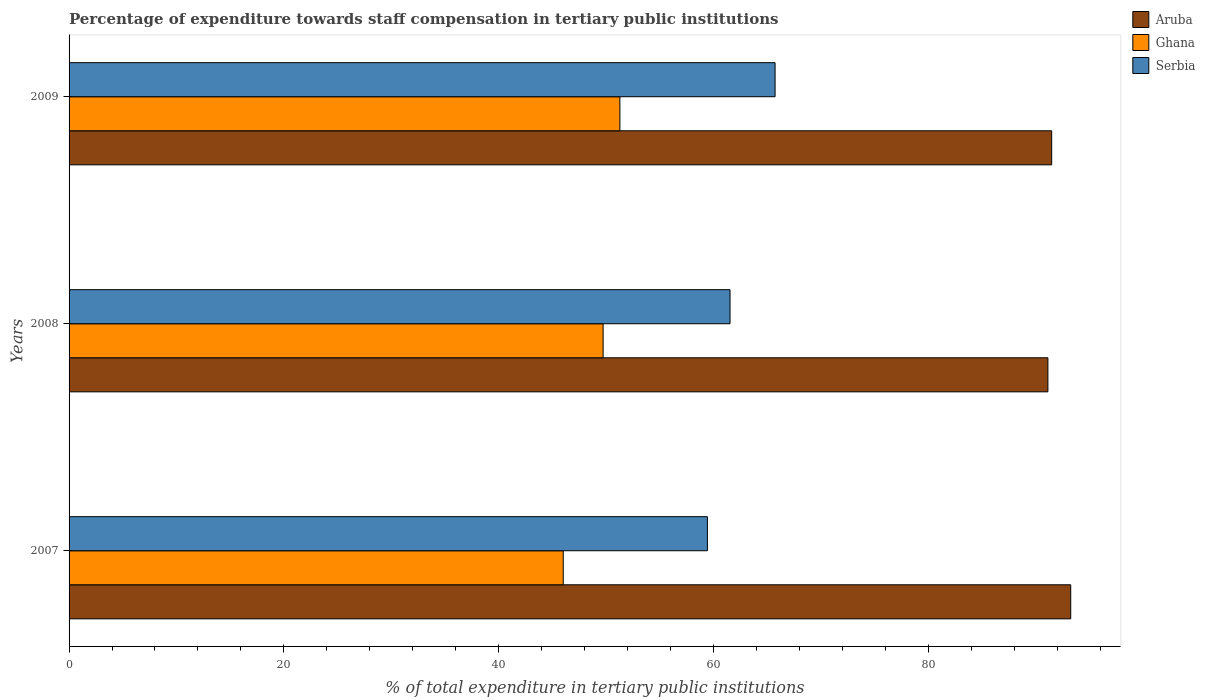How many groups of bars are there?
Keep it short and to the point. 3. Are the number of bars per tick equal to the number of legend labels?
Your answer should be compact. Yes. Are the number of bars on each tick of the Y-axis equal?
Provide a succinct answer. Yes. How many bars are there on the 1st tick from the bottom?
Provide a short and direct response. 3. What is the label of the 3rd group of bars from the top?
Make the answer very short. 2007. What is the percentage of expenditure towards staff compensation in Ghana in 2007?
Provide a short and direct response. 46.02. Across all years, what is the maximum percentage of expenditure towards staff compensation in Serbia?
Offer a terse response. 65.74. Across all years, what is the minimum percentage of expenditure towards staff compensation in Aruba?
Provide a succinct answer. 91.15. In which year was the percentage of expenditure towards staff compensation in Serbia maximum?
Provide a succinct answer. 2009. In which year was the percentage of expenditure towards staff compensation in Serbia minimum?
Give a very brief answer. 2007. What is the total percentage of expenditure towards staff compensation in Ghana in the graph?
Keep it short and to the point. 147.04. What is the difference between the percentage of expenditure towards staff compensation in Aruba in 2008 and that in 2009?
Provide a succinct answer. -0.35. What is the difference between the percentage of expenditure towards staff compensation in Serbia in 2009 and the percentage of expenditure towards staff compensation in Aruba in 2007?
Ensure brevity in your answer.  -27.53. What is the average percentage of expenditure towards staff compensation in Aruba per year?
Provide a short and direct response. 91.97. In the year 2007, what is the difference between the percentage of expenditure towards staff compensation in Serbia and percentage of expenditure towards staff compensation in Aruba?
Offer a terse response. -33.83. In how many years, is the percentage of expenditure towards staff compensation in Aruba greater than 24 %?
Keep it short and to the point. 3. What is the ratio of the percentage of expenditure towards staff compensation in Aruba in 2008 to that in 2009?
Provide a short and direct response. 1. Is the difference between the percentage of expenditure towards staff compensation in Serbia in 2007 and 2009 greater than the difference between the percentage of expenditure towards staff compensation in Aruba in 2007 and 2009?
Your answer should be compact. No. What is the difference between the highest and the second highest percentage of expenditure towards staff compensation in Aruba?
Your response must be concise. 1.77. What is the difference between the highest and the lowest percentage of expenditure towards staff compensation in Ghana?
Offer a very short reply. 5.27. Is the sum of the percentage of expenditure towards staff compensation in Aruba in 2008 and 2009 greater than the maximum percentage of expenditure towards staff compensation in Serbia across all years?
Your answer should be compact. Yes. What does the 1st bar from the top in 2009 represents?
Give a very brief answer. Serbia. What does the 3rd bar from the bottom in 2008 represents?
Offer a terse response. Serbia. Is it the case that in every year, the sum of the percentage of expenditure towards staff compensation in Ghana and percentage of expenditure towards staff compensation in Serbia is greater than the percentage of expenditure towards staff compensation in Aruba?
Offer a terse response. Yes. How many bars are there?
Make the answer very short. 9. Are all the bars in the graph horizontal?
Your response must be concise. Yes. How many years are there in the graph?
Give a very brief answer. 3. Are the values on the major ticks of X-axis written in scientific E-notation?
Your response must be concise. No. Where does the legend appear in the graph?
Ensure brevity in your answer.  Top right. What is the title of the graph?
Your answer should be very brief. Percentage of expenditure towards staff compensation in tertiary public institutions. Does "Gabon" appear as one of the legend labels in the graph?
Offer a terse response. No. What is the label or title of the X-axis?
Your answer should be compact. % of total expenditure in tertiary public institutions. What is the label or title of the Y-axis?
Provide a short and direct response. Years. What is the % of total expenditure in tertiary public institutions in Aruba in 2007?
Offer a terse response. 93.27. What is the % of total expenditure in tertiary public institutions of Ghana in 2007?
Offer a very short reply. 46.02. What is the % of total expenditure in tertiary public institutions of Serbia in 2007?
Give a very brief answer. 59.44. What is the % of total expenditure in tertiary public institutions of Aruba in 2008?
Make the answer very short. 91.15. What is the % of total expenditure in tertiary public institutions in Ghana in 2008?
Keep it short and to the point. 49.73. What is the % of total expenditure in tertiary public institutions of Serbia in 2008?
Offer a terse response. 61.55. What is the % of total expenditure in tertiary public institutions of Aruba in 2009?
Give a very brief answer. 91.5. What is the % of total expenditure in tertiary public institutions in Ghana in 2009?
Your answer should be very brief. 51.29. What is the % of total expenditure in tertiary public institutions of Serbia in 2009?
Make the answer very short. 65.74. Across all years, what is the maximum % of total expenditure in tertiary public institutions of Aruba?
Offer a terse response. 93.27. Across all years, what is the maximum % of total expenditure in tertiary public institutions of Ghana?
Your response must be concise. 51.29. Across all years, what is the maximum % of total expenditure in tertiary public institutions in Serbia?
Provide a succinct answer. 65.74. Across all years, what is the minimum % of total expenditure in tertiary public institutions of Aruba?
Your answer should be compact. 91.15. Across all years, what is the minimum % of total expenditure in tertiary public institutions in Ghana?
Your answer should be very brief. 46.02. Across all years, what is the minimum % of total expenditure in tertiary public institutions of Serbia?
Your answer should be very brief. 59.44. What is the total % of total expenditure in tertiary public institutions in Aruba in the graph?
Offer a very short reply. 275.92. What is the total % of total expenditure in tertiary public institutions in Ghana in the graph?
Your answer should be compact. 147.04. What is the total % of total expenditure in tertiary public institutions in Serbia in the graph?
Provide a succinct answer. 186.73. What is the difference between the % of total expenditure in tertiary public institutions of Aruba in 2007 and that in 2008?
Offer a terse response. 2.12. What is the difference between the % of total expenditure in tertiary public institutions in Ghana in 2007 and that in 2008?
Keep it short and to the point. -3.71. What is the difference between the % of total expenditure in tertiary public institutions in Serbia in 2007 and that in 2008?
Your answer should be compact. -2.11. What is the difference between the % of total expenditure in tertiary public institutions of Aruba in 2007 and that in 2009?
Your response must be concise. 1.77. What is the difference between the % of total expenditure in tertiary public institutions of Ghana in 2007 and that in 2009?
Offer a terse response. -5.27. What is the difference between the % of total expenditure in tertiary public institutions of Serbia in 2007 and that in 2009?
Ensure brevity in your answer.  -6.3. What is the difference between the % of total expenditure in tertiary public institutions in Aruba in 2008 and that in 2009?
Your answer should be compact. -0.35. What is the difference between the % of total expenditure in tertiary public institutions in Ghana in 2008 and that in 2009?
Offer a terse response. -1.56. What is the difference between the % of total expenditure in tertiary public institutions of Serbia in 2008 and that in 2009?
Give a very brief answer. -4.19. What is the difference between the % of total expenditure in tertiary public institutions in Aruba in 2007 and the % of total expenditure in tertiary public institutions in Ghana in 2008?
Keep it short and to the point. 43.54. What is the difference between the % of total expenditure in tertiary public institutions of Aruba in 2007 and the % of total expenditure in tertiary public institutions of Serbia in 2008?
Ensure brevity in your answer.  31.72. What is the difference between the % of total expenditure in tertiary public institutions in Ghana in 2007 and the % of total expenditure in tertiary public institutions in Serbia in 2008?
Give a very brief answer. -15.53. What is the difference between the % of total expenditure in tertiary public institutions of Aruba in 2007 and the % of total expenditure in tertiary public institutions of Ghana in 2009?
Make the answer very short. 41.98. What is the difference between the % of total expenditure in tertiary public institutions in Aruba in 2007 and the % of total expenditure in tertiary public institutions in Serbia in 2009?
Provide a short and direct response. 27.53. What is the difference between the % of total expenditure in tertiary public institutions in Ghana in 2007 and the % of total expenditure in tertiary public institutions in Serbia in 2009?
Ensure brevity in your answer.  -19.73. What is the difference between the % of total expenditure in tertiary public institutions of Aruba in 2008 and the % of total expenditure in tertiary public institutions of Ghana in 2009?
Offer a terse response. 39.86. What is the difference between the % of total expenditure in tertiary public institutions of Aruba in 2008 and the % of total expenditure in tertiary public institutions of Serbia in 2009?
Provide a short and direct response. 25.41. What is the difference between the % of total expenditure in tertiary public institutions in Ghana in 2008 and the % of total expenditure in tertiary public institutions in Serbia in 2009?
Make the answer very short. -16.01. What is the average % of total expenditure in tertiary public institutions of Aruba per year?
Provide a succinct answer. 91.97. What is the average % of total expenditure in tertiary public institutions in Ghana per year?
Give a very brief answer. 49.01. What is the average % of total expenditure in tertiary public institutions of Serbia per year?
Your response must be concise. 62.24. In the year 2007, what is the difference between the % of total expenditure in tertiary public institutions of Aruba and % of total expenditure in tertiary public institutions of Ghana?
Offer a terse response. 47.26. In the year 2007, what is the difference between the % of total expenditure in tertiary public institutions of Aruba and % of total expenditure in tertiary public institutions of Serbia?
Your response must be concise. 33.83. In the year 2007, what is the difference between the % of total expenditure in tertiary public institutions in Ghana and % of total expenditure in tertiary public institutions in Serbia?
Your answer should be compact. -13.42. In the year 2008, what is the difference between the % of total expenditure in tertiary public institutions in Aruba and % of total expenditure in tertiary public institutions in Ghana?
Offer a very short reply. 41.42. In the year 2008, what is the difference between the % of total expenditure in tertiary public institutions of Aruba and % of total expenditure in tertiary public institutions of Serbia?
Provide a succinct answer. 29.6. In the year 2008, what is the difference between the % of total expenditure in tertiary public institutions in Ghana and % of total expenditure in tertiary public institutions in Serbia?
Ensure brevity in your answer.  -11.82. In the year 2009, what is the difference between the % of total expenditure in tertiary public institutions of Aruba and % of total expenditure in tertiary public institutions of Ghana?
Give a very brief answer. 40.21. In the year 2009, what is the difference between the % of total expenditure in tertiary public institutions of Aruba and % of total expenditure in tertiary public institutions of Serbia?
Ensure brevity in your answer.  25.76. In the year 2009, what is the difference between the % of total expenditure in tertiary public institutions in Ghana and % of total expenditure in tertiary public institutions in Serbia?
Give a very brief answer. -14.45. What is the ratio of the % of total expenditure in tertiary public institutions of Aruba in 2007 to that in 2008?
Give a very brief answer. 1.02. What is the ratio of the % of total expenditure in tertiary public institutions in Ghana in 2007 to that in 2008?
Give a very brief answer. 0.93. What is the ratio of the % of total expenditure in tertiary public institutions of Serbia in 2007 to that in 2008?
Keep it short and to the point. 0.97. What is the ratio of the % of total expenditure in tertiary public institutions in Aruba in 2007 to that in 2009?
Offer a very short reply. 1.02. What is the ratio of the % of total expenditure in tertiary public institutions of Ghana in 2007 to that in 2009?
Ensure brevity in your answer.  0.9. What is the ratio of the % of total expenditure in tertiary public institutions of Serbia in 2007 to that in 2009?
Your answer should be compact. 0.9. What is the ratio of the % of total expenditure in tertiary public institutions of Ghana in 2008 to that in 2009?
Offer a terse response. 0.97. What is the ratio of the % of total expenditure in tertiary public institutions of Serbia in 2008 to that in 2009?
Give a very brief answer. 0.94. What is the difference between the highest and the second highest % of total expenditure in tertiary public institutions in Aruba?
Keep it short and to the point. 1.77. What is the difference between the highest and the second highest % of total expenditure in tertiary public institutions of Ghana?
Your answer should be very brief. 1.56. What is the difference between the highest and the second highest % of total expenditure in tertiary public institutions of Serbia?
Provide a short and direct response. 4.19. What is the difference between the highest and the lowest % of total expenditure in tertiary public institutions in Aruba?
Your answer should be compact. 2.12. What is the difference between the highest and the lowest % of total expenditure in tertiary public institutions of Ghana?
Your answer should be very brief. 5.27. What is the difference between the highest and the lowest % of total expenditure in tertiary public institutions of Serbia?
Your response must be concise. 6.3. 